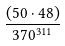Convert formula to latex. <formula><loc_0><loc_0><loc_500><loc_500>\frac { ( 5 0 \cdot 4 8 ) } { 3 7 0 ^ { 3 1 1 } }</formula> 